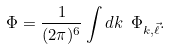<formula> <loc_0><loc_0><loc_500><loc_500>\Phi = \frac { 1 } { ( 2 \pi ) ^ { 6 } } \int d k \ \Phi _ { k , \vec { \ell } } .</formula> 